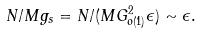<formula> <loc_0><loc_0><loc_500><loc_500>N / M g _ { s } = N / ( M G _ { o ( 1 ) } ^ { 2 } \epsilon ) \sim \epsilon .</formula> 